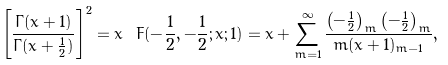Convert formula to latex. <formula><loc_0><loc_0><loc_500><loc_500>\left [ \frac { \Gamma ( x + 1 ) } { \Gamma ( x + \frac { 1 } { 2 } ) } \right ] ^ { 2 } = x \ F ( - \frac { 1 } { 2 } , - \frac { 1 } { 2 } ; x ; 1 ) = x + \sum _ { m = 1 } ^ { \infty } \frac { \left ( - \frac { 1 } { 2 } \right ) _ { m } \left ( - \frac { 1 } { 2 } \right ) _ { m } } { m ( x + 1 ) _ { m - 1 } } ,</formula> 